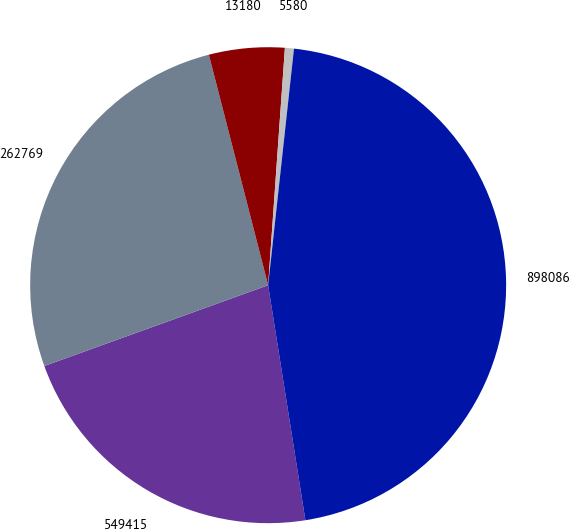Convert chart to OTSL. <chart><loc_0><loc_0><loc_500><loc_500><pie_chart><fcel>549415<fcel>262769<fcel>13180<fcel>5580<fcel>898086<nl><fcel>21.99%<fcel>26.51%<fcel>5.13%<fcel>0.61%<fcel>45.77%<nl></chart> 